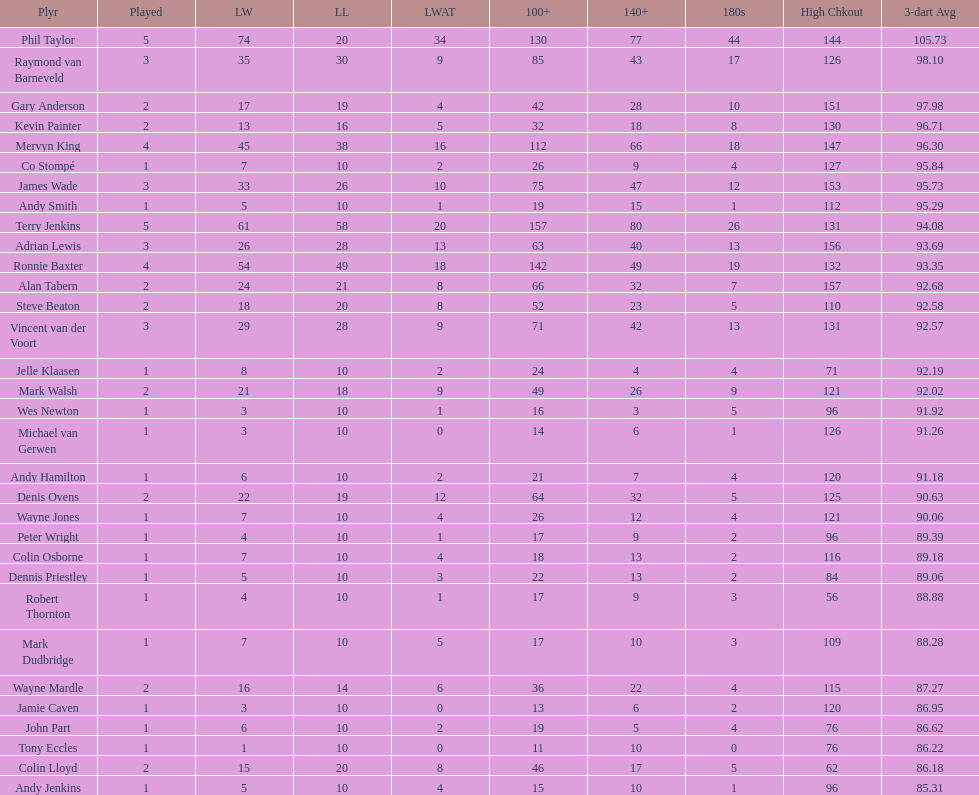What were the total number of legs won by ronnie baxter? 54. 